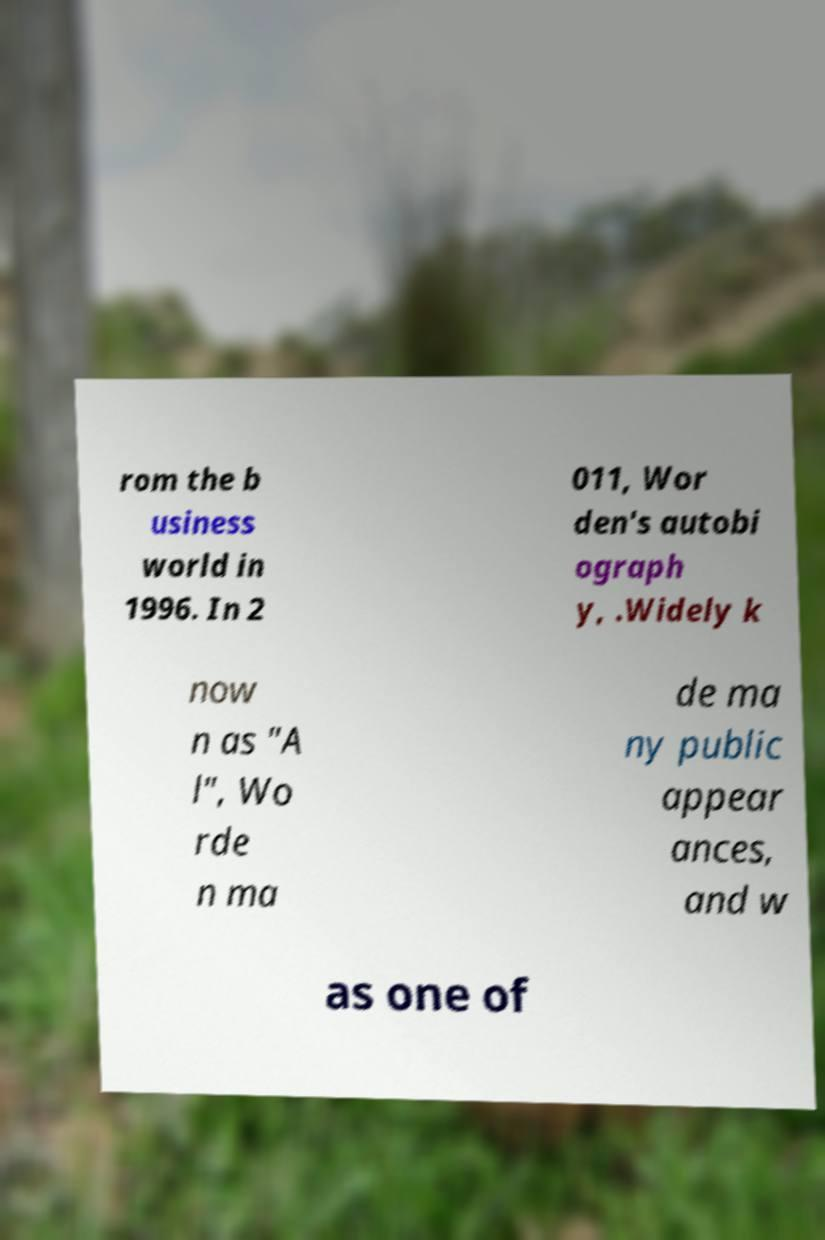What messages or text are displayed in this image? I need them in a readable, typed format. rom the b usiness world in 1996. In 2 011, Wor den's autobi ograph y, .Widely k now n as "A l", Wo rde n ma de ma ny public appear ances, and w as one of 